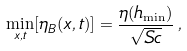Convert formula to latex. <formula><loc_0><loc_0><loc_500><loc_500>\min _ { { x } , t } [ \eta _ { B } ( { x } , t ) ] = \frac { \eta ( h _ { \min } ) } { \sqrt { S c } } \, ,</formula> 